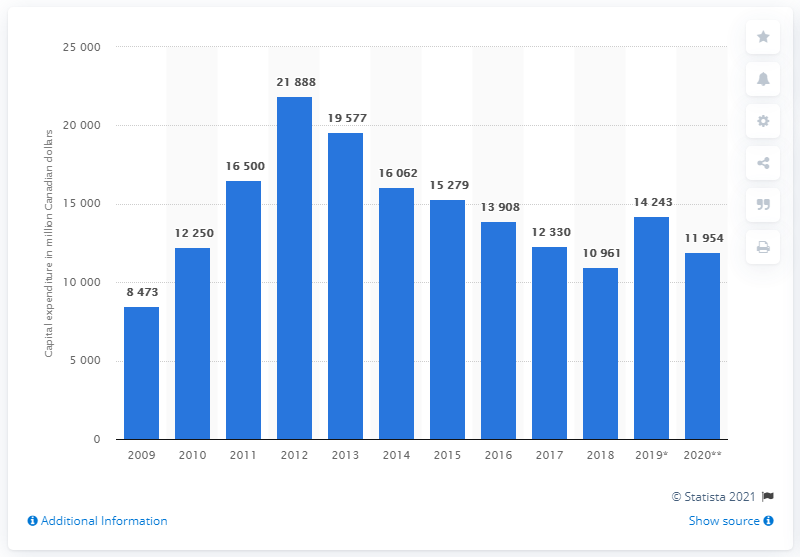Highlight a few significant elements in this photo. According to data from 2019, the capital expenditure on mining and mineral processing in Canada was 14,243. 